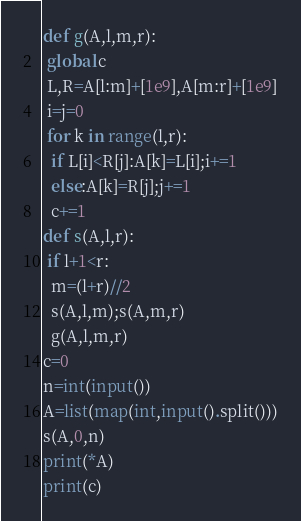<code> <loc_0><loc_0><loc_500><loc_500><_Python_>def g(A,l,m,r):
 global c
 L,R=A[l:m]+[1e9],A[m:r]+[1e9]
 i=j=0
 for k in range(l,r):
  if L[i]<R[j]:A[k]=L[i];i+=1
  else:A[k]=R[j];j+=1
  c+=1
def s(A,l,r):
 if l+1<r:
  m=(l+r)//2
  s(A,l,m);s(A,m,r)
  g(A,l,m,r)
c=0
n=int(input())
A=list(map(int,input().split()))
s(A,0,n)
print(*A)
print(c)
</code> 